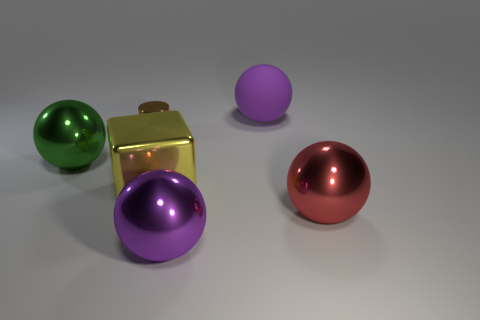Subtract all red shiny spheres. How many spheres are left? 3 Subtract all red balls. How many balls are left? 3 Add 1 yellow metallic cubes. How many objects exist? 7 Subtract all cyan cylinders. How many purple spheres are left? 2 Subtract all cylinders. How many objects are left? 5 Subtract 1 cylinders. How many cylinders are left? 0 Subtract all tiny cylinders. Subtract all large green shiny balls. How many objects are left? 4 Add 3 big yellow metal things. How many big yellow metal things are left? 4 Add 5 small matte objects. How many small matte objects exist? 5 Subtract 0 green cubes. How many objects are left? 6 